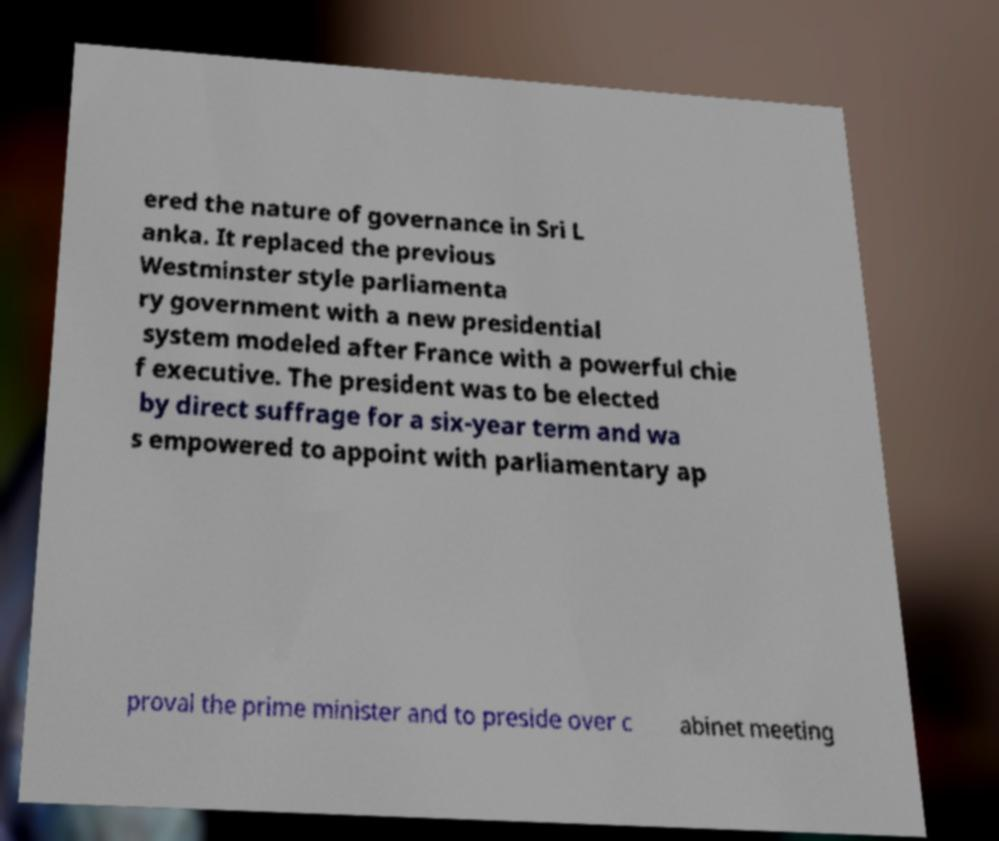Please identify and transcribe the text found in this image. ered the nature of governance in Sri L anka. It replaced the previous Westminster style parliamenta ry government with a new presidential system modeled after France with a powerful chie f executive. The president was to be elected by direct suffrage for a six-year term and wa s empowered to appoint with parliamentary ap proval the prime minister and to preside over c abinet meeting 